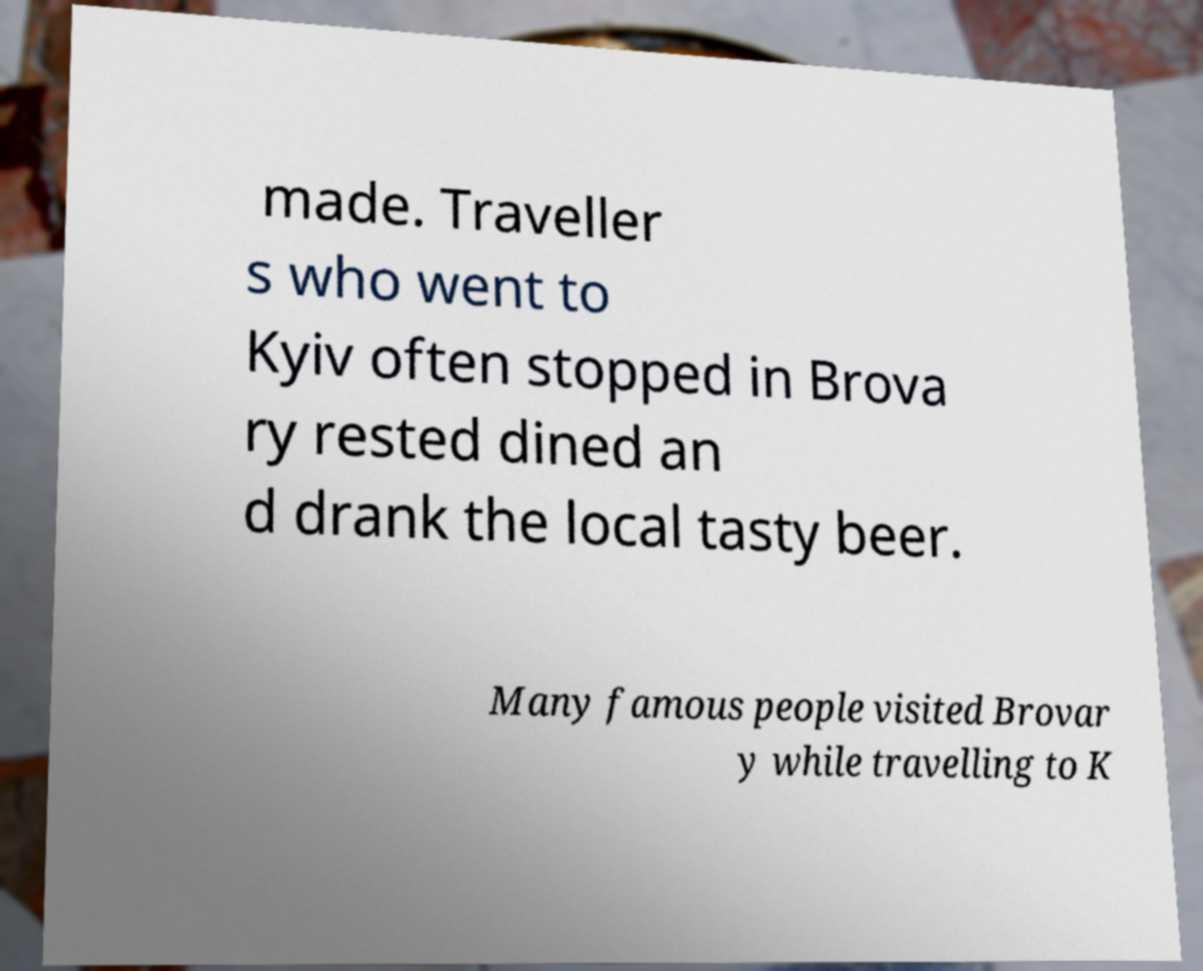There's text embedded in this image that I need extracted. Can you transcribe it verbatim? made. Traveller s who went to Kyiv often stopped in Brova ry rested dined an d drank the local tasty beer. Many famous people visited Brovar y while travelling to K 